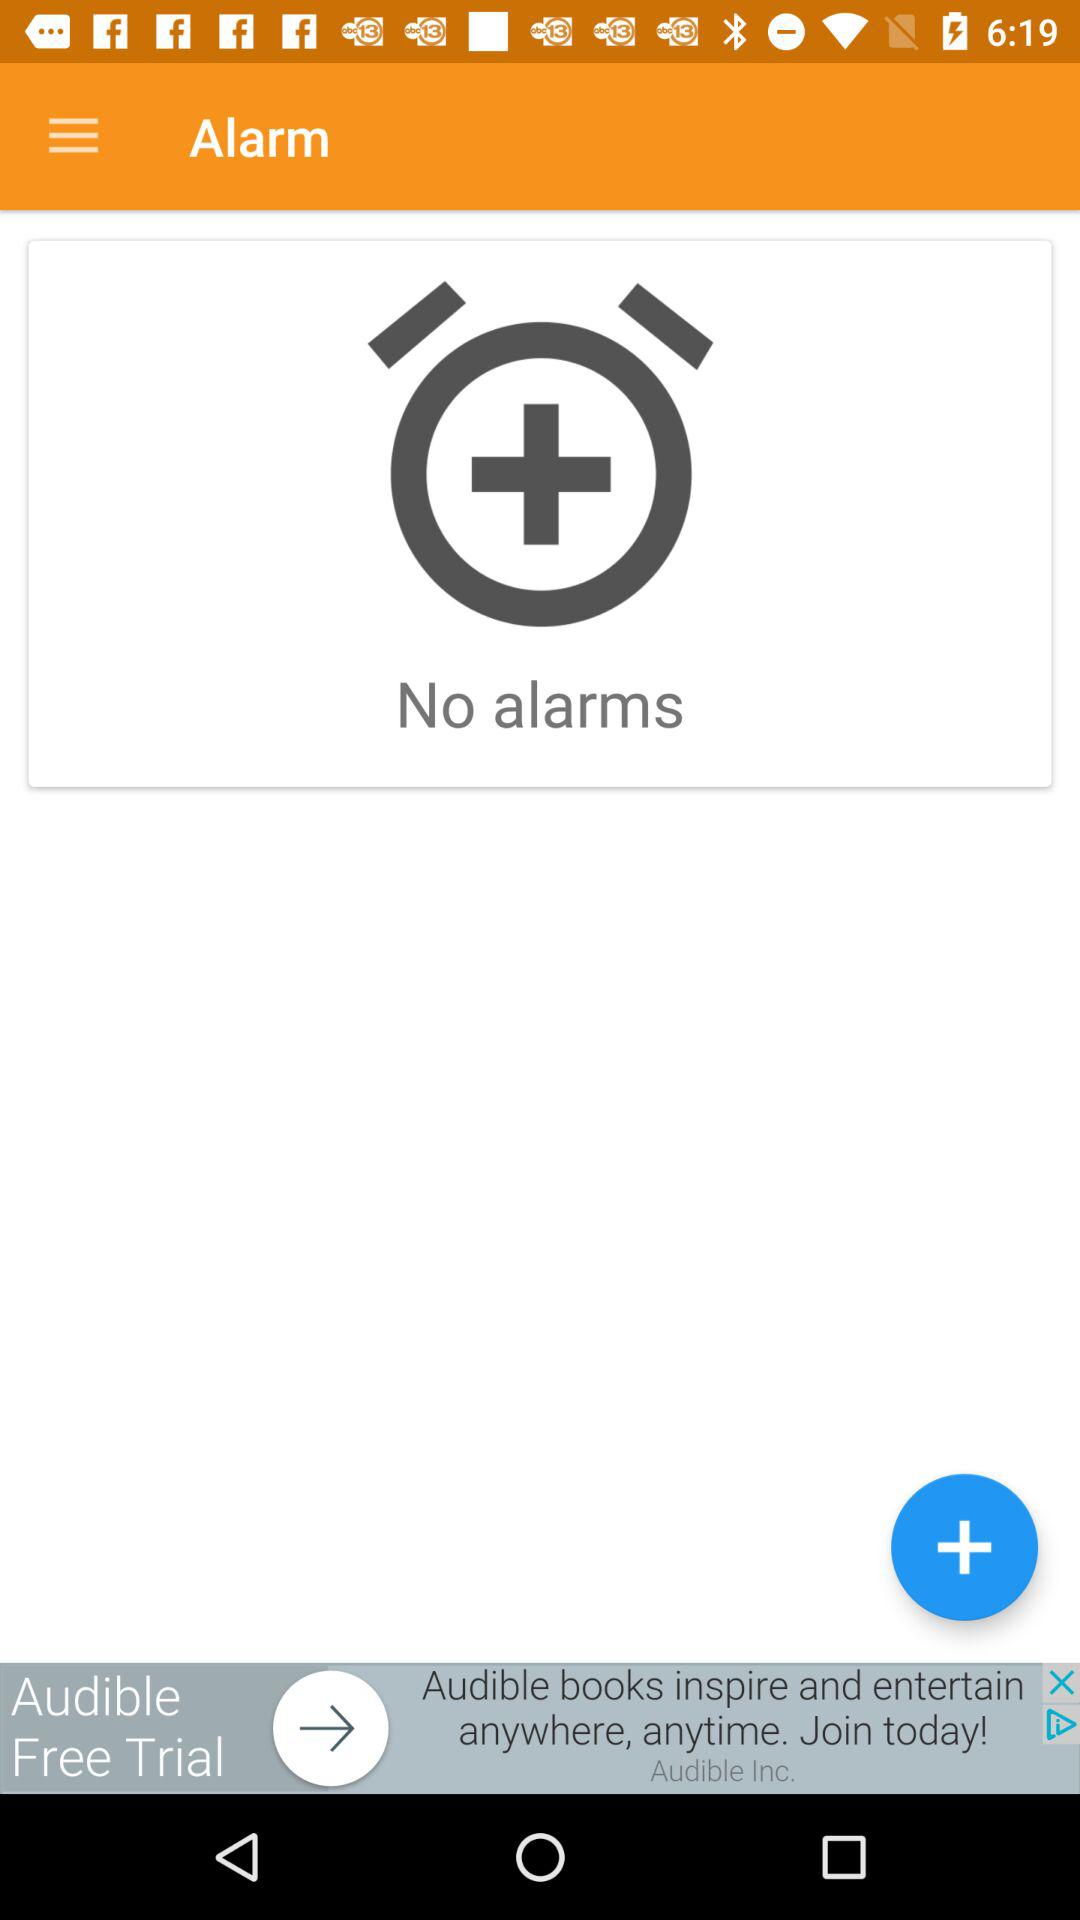Are there any alarms? There are no alarms. 